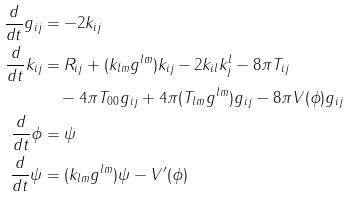Convert formula to latex. <formula><loc_0><loc_0><loc_500><loc_500>\frac { d } { d t } g _ { i j } & = - 2 k _ { i j } \\ \frac { d } { d t } k _ { i j } & = R _ { i j } + ( k _ { l m } g ^ { l m } ) k _ { i j } - 2 k _ { i l } k ^ { l } _ { j } - 8 \pi T _ { i j } \\ & \quad - 4 \pi T _ { 0 0 } g _ { i j } + 4 \pi ( T _ { l m } g ^ { l m } ) g _ { i j } - 8 \pi V ( \phi ) g _ { i j } \\ \frac { d } { d t } \phi & = \psi \\ \frac { d } { d t } \psi & = ( k _ { l m } g ^ { l m } ) \psi - V ^ { \prime } ( \phi )</formula> 